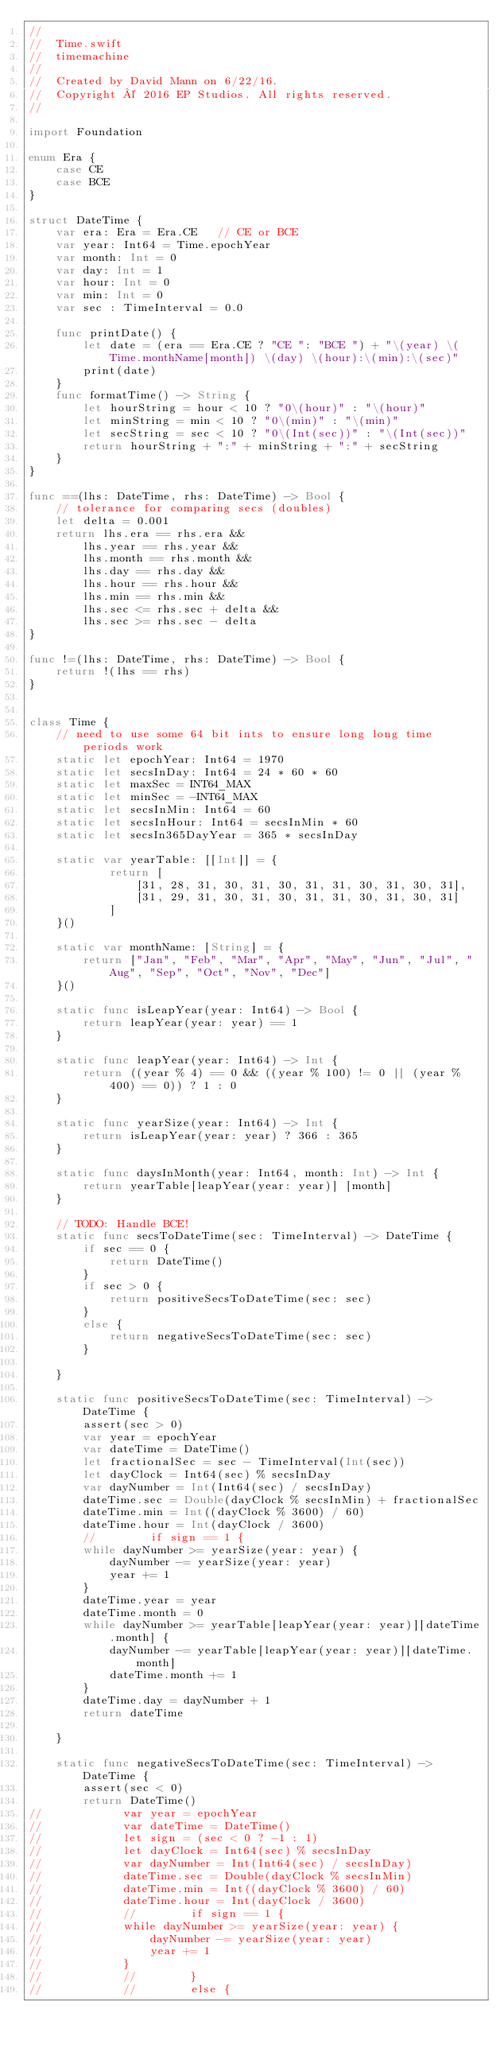<code> <loc_0><loc_0><loc_500><loc_500><_Swift_>//
//  Time.swift
//  timemachine
//
//  Created by David Mann on 6/22/16.
//  Copyright © 2016 EP Studios. All rights reserved.
//

import Foundation

enum Era {
    case CE
    case BCE
}

struct DateTime {
    var era: Era = Era.CE   // CE or BCE
    var year: Int64 = Time.epochYear
    var month: Int = 0
    var day: Int = 1
    var hour: Int = 0
    var min: Int = 0
    var sec : TimeInterval = 0.0
    
    func printDate() {
        let date = (era == Era.CE ? "CE ": "BCE ") + "\(year) \(Time.monthName[month]) \(day) \(hour):\(min):\(sec)"
        print(date)
    }
    func formatTime() -> String {
        let hourString = hour < 10 ? "0\(hour)" : "\(hour)"
        let minString = min < 10 ? "0\(min)" : "\(min)"
        let secString = sec < 10 ? "0\(Int(sec))" : "\(Int(sec))"
        return hourString + ":" + minString + ":" + secString
    }
}

func ==(lhs: DateTime, rhs: DateTime) -> Bool {
    // tolerance for comparing secs (doubles)
    let delta = 0.001
    return lhs.era == rhs.era &&
        lhs.year == rhs.year &&
        lhs.month == rhs.month &&
        lhs.day == rhs.day &&
        lhs.hour == rhs.hour &&
        lhs.min == rhs.min &&
        lhs.sec <= rhs.sec + delta &&
        lhs.sec >= rhs.sec - delta
}

func !=(lhs: DateTime, rhs: DateTime) -> Bool {
    return !(lhs == rhs)
}


class Time {
    // need to use some 64 bit ints to ensure long long time periods work
    static let epochYear: Int64 = 1970
    static let secsInDay: Int64 = 24 * 60 * 60
    static let maxSec = INT64_MAX
    static let minSec = -INT64_MAX
    static let secsInMin: Int64 = 60
    static let secsInHour: Int64 = secsInMin * 60
    static let secsIn365DayYear = 365 * secsInDay
        
    static var yearTable: [[Int]] = {
            return [
                [31, 28, 31, 30, 31, 30, 31, 31, 30, 31, 30, 31],
                [31, 29, 31, 30, 31, 30, 31, 31, 30, 31, 30, 31]
            ]
    }()
    
    static var monthName: [String] = {
        return ["Jan", "Feb", "Mar", "Apr", "May", "Jun", "Jul", "Aug", "Sep", "Oct", "Nov", "Dec"]
    }()

    static func isLeapYear(year: Int64) -> Bool {
        return leapYear(year: year) == 1
    }
    
    static func leapYear(year: Int64) -> Int {
        return ((year % 4) == 0 && ((year % 100) != 0 || (year % 400) == 0)) ? 1 : 0
    }
    
    static func yearSize(year: Int64) -> Int {
        return isLeapYear(year: year) ? 366 : 365
    }
    
    static func daysInMonth(year: Int64, month: Int) -> Int {
        return yearTable[leapYear(year: year)] [month]
    }
    
    // TODO: Handle BCE!
    static func secsToDateTime(sec: TimeInterval) -> DateTime {
        if sec == 0 {
            return DateTime()
        }
        if sec > 0 {
            return positiveSecsToDateTime(sec: sec)
        }
        else {
            return negativeSecsToDateTime(sec: sec)
        }
        
    }
    
    static func positiveSecsToDateTime(sec: TimeInterval) -> DateTime {
        assert(sec > 0)
        var year = epochYear
        var dateTime = DateTime()
        let fractionalSec = sec - TimeInterval(Int(sec))
        let dayClock = Int64(sec) % secsInDay
        var dayNumber = Int(Int64(sec) / secsInDay)
        dateTime.sec = Double(dayClock % secsInMin) + fractionalSec
        dateTime.min = Int((dayClock % 3600) / 60)
        dateTime.hour = Int(dayClock / 3600)
        //        if sign == 1 {
        while dayNumber >= yearSize(year: year) {
            dayNumber -= yearSize(year: year)
            year += 1
        }
        dateTime.year = year
        dateTime.month = 0
        while dayNumber >= yearTable[leapYear(year: year)][dateTime.month] {
            dayNumber -= yearTable[leapYear(year: year)][dateTime.month]
            dateTime.month += 1
        }
        dateTime.day = dayNumber + 1
        return dateTime
        
    }
        
    static func negativeSecsToDateTime(sec: TimeInterval) -> DateTime {
        assert(sec < 0)
        return DateTime()
//            var year = epochYear
//            var dateTime = DateTime()
//            let sign = (sec < 0 ? -1 : 1)
//            let dayClock = Int64(sec) % secsInDay
//            var dayNumber = Int(Int64(sec) / secsInDay)
//            dateTime.sec = Double(dayClock % secsInMin)
//            dateTime.min = Int((dayClock % 3600) / 60)
//            dateTime.hour = Int(dayClock / 3600)
//            //        if sign == 1 {
//            while dayNumber >= yearSize(year: year) {
//                dayNumber -= yearSize(year: year)
//                year += 1
//            }
//            //        }
//            //        else {</code> 